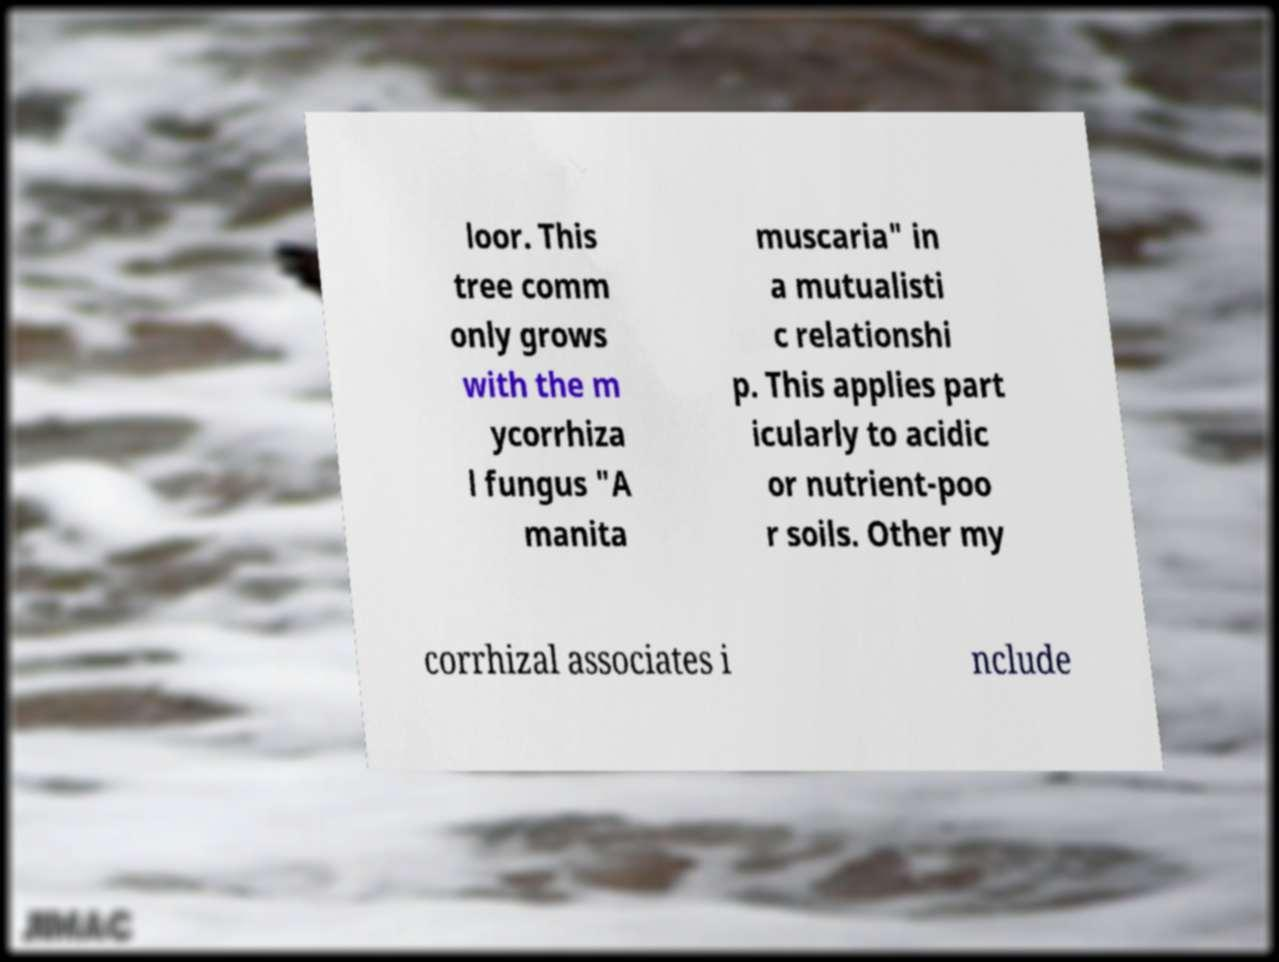What messages or text are displayed in this image? I need them in a readable, typed format. loor. This tree comm only grows with the m ycorrhiza l fungus "A manita muscaria" in a mutualisti c relationshi p. This applies part icularly to acidic or nutrient-poo r soils. Other my corrhizal associates i nclude 